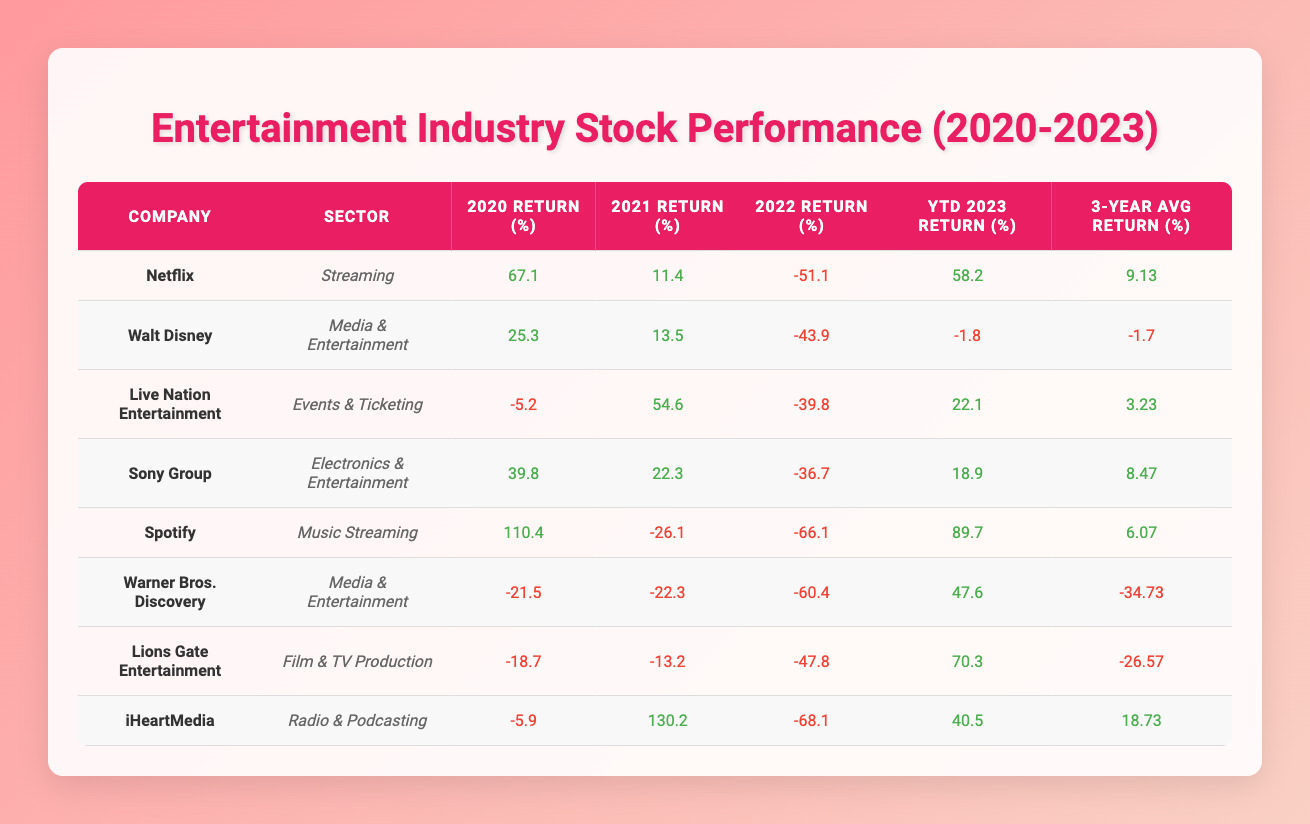What was the highest return percentage for Netflix in the given years? Looking at the data for Netflix, the returns were 67.1% in 2020, 11.4% in 2021, -51.1% in 2022, and 58.2% year-to-date in 2023. The highest return is 67.1% in 2020.
Answer: 67.1% Which company had the lowest return in 2022? Checking the 2022 return column, Warner Bros. Discovery had the lowest return at -60.4%.
Answer: -60.4% What is the 3-Year Average Return for iHeartMedia? From the data, iHeartMedia's 3-Year Average Return is 18.73%.
Answer: 18.73% Did any company have a return over 100% in 2020? Upon reviewing the data, Spotify had a return of 110.4% in 2020, confirming that yes, it did.
Answer: Yes What was the average return for the companies in the Media & Entertainment sector over the three years? For Walt Disney (-1.7%), Warner Bros. Discovery (-34.73%), and both positive and negative returns in the sector, taking the average of -1.7% and -34.73% gives us (-1.7 - 34.73) / 2 = -18.215%.
Answer: -18.215% Which company improved its performance the most from 2022 to 2023 in terms of return? Analyzing the YTD returns, Warner Bros. Discovery climbed from -60.4% in 2022 to 47.6% in 2023 for an improvement of 108%.
Answer: Warner Bros. Discovery What is the percentage difference in returns between 2020 and 2021 for Sony Group? For Sony Group, the return in 2020 was 39.8% and in 2021 it was 22.3%. The difference is 39.8 - 22.3 = 17.5%.
Answer: 17.5% Which company had the most consistent performance as indicated by a positive 3-Year Average Return? Only Netflix (9.13%), Sony Group (8.47%), and iHeartMedia (18.73%) had positive average returns, but iHeartMedia has the highest consistency in positive performance.
Answer: iHeartMedia 